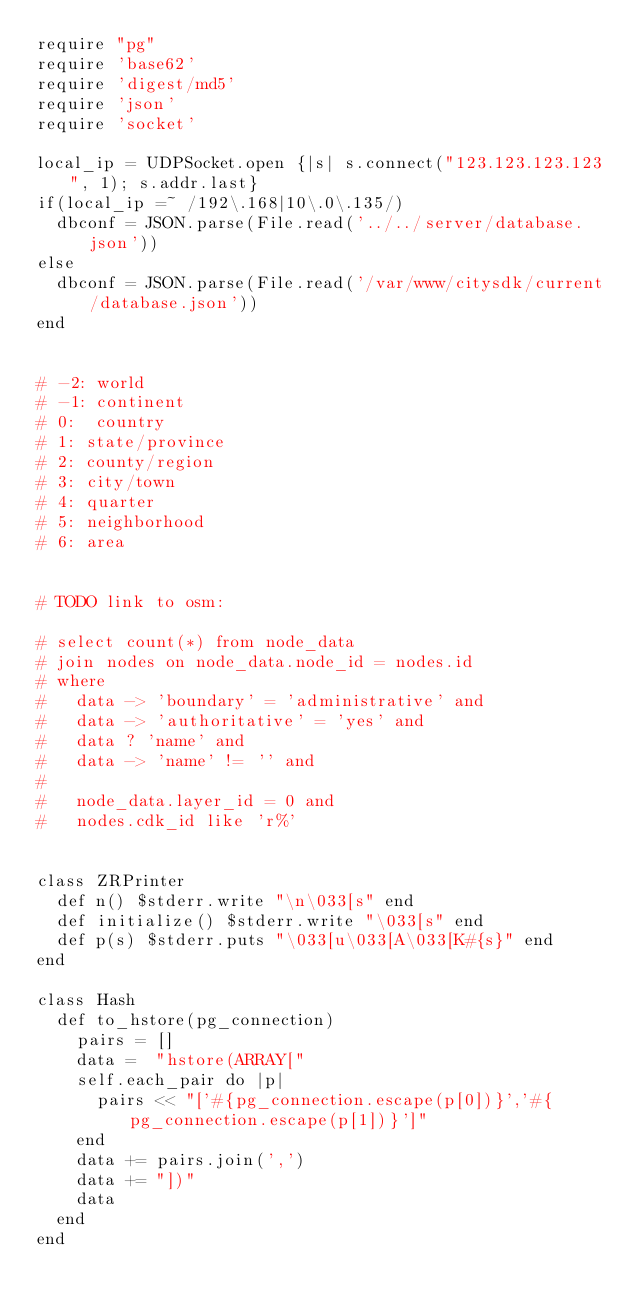Convert code to text. <code><loc_0><loc_0><loc_500><loc_500><_Ruby_>require "pg"
require 'base62'
require 'digest/md5'
require 'json'
require 'socket'

local_ip = UDPSocket.open {|s| s.connect("123.123.123.123", 1); s.addr.last}
if(local_ip =~ /192\.168|10\.0\.135/)
  dbconf = JSON.parse(File.read('../../server/database.json'))
else
  dbconf = JSON.parse(File.read('/var/www/citysdk/current/database.json'))
end


# -2: world
# -1: continent
# 0:  country
# 1: state/province
# 2: county/region
# 3: city/town
# 4: quarter
# 5: neighborhood
# 6: area 


# TODO link to osm:

# select count(*) from node_data 
# join nodes on node_data.node_id = nodes.id
# where 
#   data -> 'boundary' = 'administrative' and
#   data -> 'authoritative' = 'yes' and
#   data ? 'name' and
#   data -> 'name' != '' and
#   
#   node_data.layer_id = 0 and
#   nodes.cdk_id like 'r%'
  

class ZRPrinter
  def n() $stderr.write "\n\033[s" end
  def initialize() $stderr.write "\033[s" end
  def p(s) $stderr.puts "\033[u\033[A\033[K#{s}" end
end

class Hash
  def to_hstore(pg_connection)
    pairs = []
    data =  "hstore(ARRAY["
    self.each_pair do |p|
      pairs << "['#{pg_connection.escape(p[0])}','#{pg_connection.escape(p[1])}']"
    end
    data += pairs.join(',')
    data += "])"
    data
  end
end


</code> 